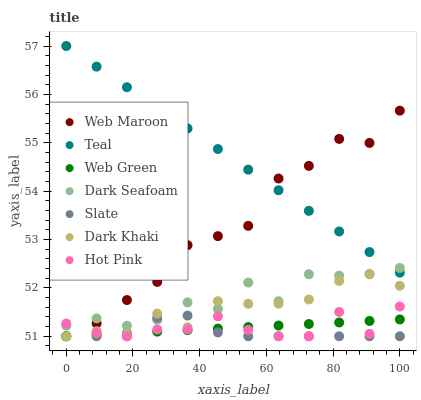Does Slate have the minimum area under the curve?
Answer yes or no. Yes. Does Teal have the maximum area under the curve?
Answer yes or no. Yes. Does Hot Pink have the minimum area under the curve?
Answer yes or no. No. Does Hot Pink have the maximum area under the curve?
Answer yes or no. No. Is Web Green the smoothest?
Answer yes or no. Yes. Is Dark Seafoam the roughest?
Answer yes or no. Yes. Is Hot Pink the smoothest?
Answer yes or no. No. Is Hot Pink the roughest?
Answer yes or no. No. Does Slate have the lowest value?
Answer yes or no. Yes. Does Dark Seafoam have the lowest value?
Answer yes or no. No. Does Teal have the highest value?
Answer yes or no. Yes. Does Hot Pink have the highest value?
Answer yes or no. No. Is Slate less than Teal?
Answer yes or no. Yes. Is Teal greater than Slate?
Answer yes or no. Yes. Does Web Maroon intersect Teal?
Answer yes or no. Yes. Is Web Maroon less than Teal?
Answer yes or no. No. Is Web Maroon greater than Teal?
Answer yes or no. No. Does Slate intersect Teal?
Answer yes or no. No. 